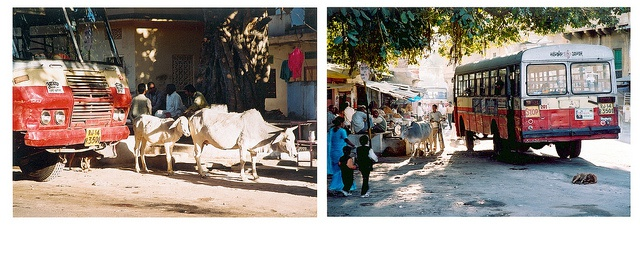Describe the objects in this image and their specific colors. I can see bus in white, black, lightgray, salmon, and gray tones, bus in white, black, lightgray, darkgray, and gray tones, cow in white, lightgray, tan, and gray tones, cow in white, gray, and tan tones, and people in white, blue, black, and navy tones in this image. 